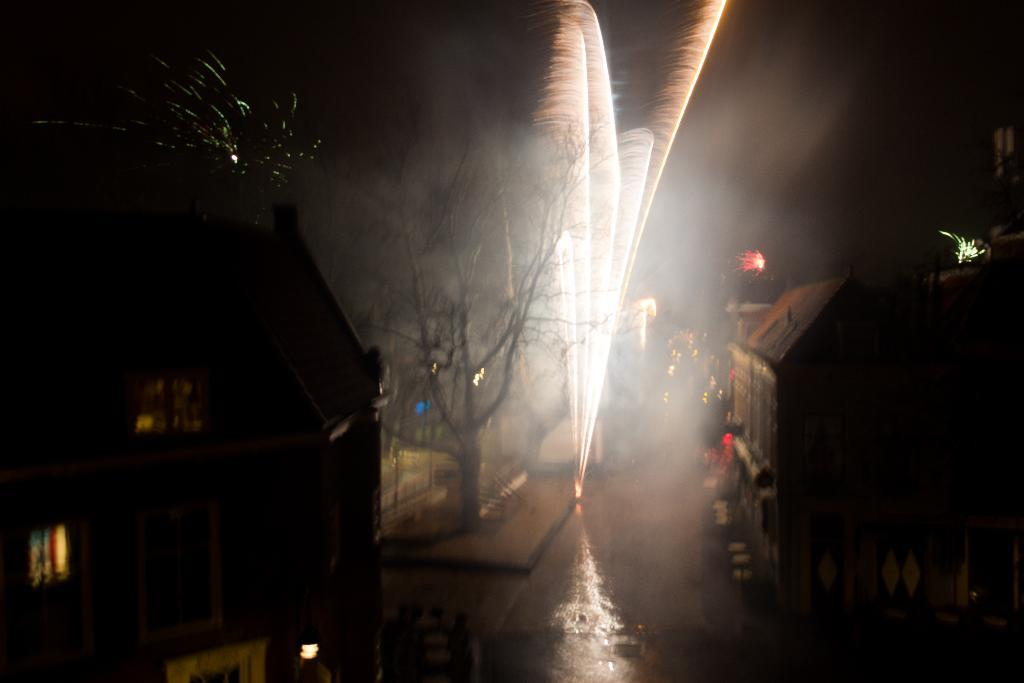What type of structures are visible in the image? There are houses with windows in the image. What natural element is present in the image? There is a tree in the image. What objects are present that might make noise? Firecrackers are present in the image. What type of agreement is being discussed in the image? There is no indication of an agreement being discussed in the image. Can you see a fork in the image? There is no fork present in the image. 